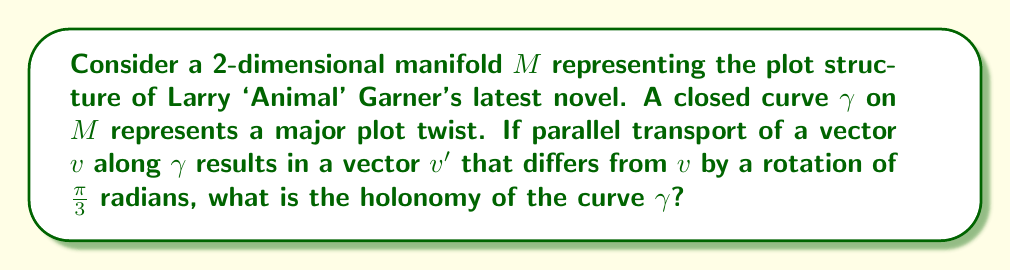Can you solve this math problem? To solve this problem, we'll follow these steps:

1) Holonomy is a measure of how parallel transport around a closed curve fails to return a vector to its original orientation. It's represented by an element of the holonomy group, which for a 2D manifold is a subgroup of SO(2), the group of rotations in 2D.

2) In this case, we're told that parallel transport along $\gamma$ rotates a vector by $\frac{\pi}{3}$ radians.

3) The holonomy of the curve is precisely this rotation. We can represent it as an element of SO(2) using a rotation matrix:

   $$R = \begin{pmatrix}
   \cos(\frac{\pi}{3}) & -\sin(\frac{\pi}{3}) \\
   \sin(\frac{\pi}{3}) & \cos(\frac{\pi}{3})
   \end{pmatrix}$$

4) This matrix represents a counterclockwise rotation by $\frac{\pi}{3}$ radians.

5) In terms of group theory, the holonomy group generated by this curve is the cyclic subgroup of SO(2) generated by this rotation.

6) The holonomy can also be related to the curvature of the manifold via the holonomy theorem, which states that for a simply connected manifold, the holonomy group is generated by the curvature tensor. This suggests that the plot twist (represented by $\gamma$) occurs in a region of non-zero curvature in the plot structure manifold.
Answer: $\frac{\pi}{3}$ radians counterclockwise rotation 